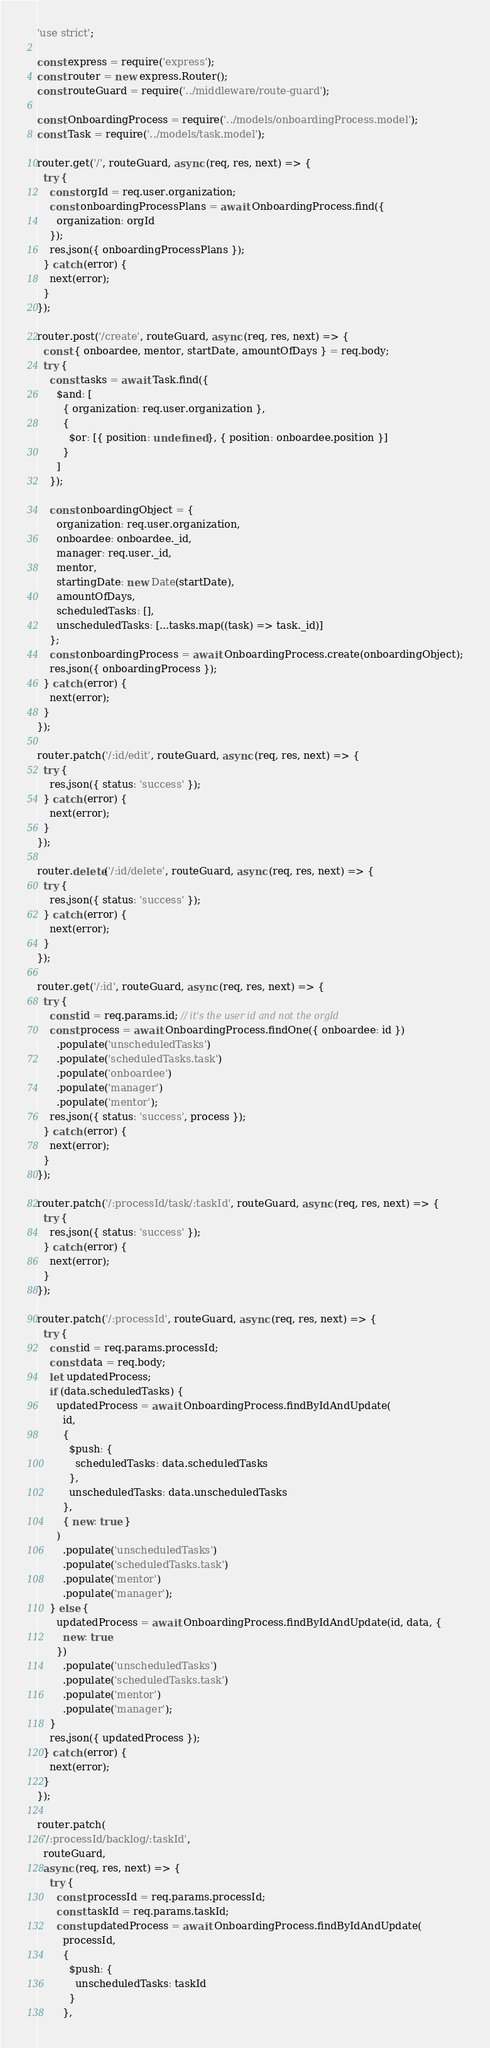<code> <loc_0><loc_0><loc_500><loc_500><_JavaScript_>'use strict';

const express = require('express');
const router = new express.Router();
const routeGuard = require('../middleware/route-guard');

const OnboardingProcess = require('../models/onboardingProcess.model');
const Task = require('../models/task.model');

router.get('/', routeGuard, async (req, res, next) => {
  try {
    const orgId = req.user.organization;
    const onboardingProcessPlans = await OnboardingProcess.find({
      organization: orgId
    });
    res.json({ onboardingProcessPlans });
  } catch (error) {
    next(error);
  }
});

router.post('/create', routeGuard, async (req, res, next) => {
  const { onboardee, mentor, startDate, amountOfDays } = req.body;
  try {
    const tasks = await Task.find({
      $and: [
        { organization: req.user.organization },
        {
          $or: [{ position: undefined }, { position: onboardee.position }]
        }
      ]
    });

    const onboardingObject = {
      organization: req.user.organization,
      onboardee: onboardee._id,
      manager: req.user._id,
      mentor,
      startingDate: new Date(startDate),
      amountOfDays,
      scheduledTasks: [],
      unscheduledTasks: [...tasks.map((task) => task._id)]
    };
    const onboardingProcess = await OnboardingProcess.create(onboardingObject);
    res.json({ onboardingProcess });
  } catch (error) {
    next(error);
  }
});

router.patch('/:id/edit', routeGuard, async (req, res, next) => {
  try {
    res.json({ status: 'success' });
  } catch (error) {
    next(error);
  }
});

router.delete('/:id/delete', routeGuard, async (req, res, next) => {
  try {
    res.json({ status: 'success' });
  } catch (error) {
    next(error);
  }
});

router.get('/:id', routeGuard, async (req, res, next) => {
  try {
    const id = req.params.id; // it's the user id and not the orgId
    const process = await OnboardingProcess.findOne({ onboardee: id })
      .populate('unscheduledTasks')
      .populate('scheduledTasks.task')
      .populate('onboardee')
      .populate('manager')
      .populate('mentor');
    res.json({ status: 'success', process });
  } catch (error) {
    next(error);
  }
});

router.patch('/:processId/task/:taskId', routeGuard, async (req, res, next) => {
  try {
    res.json({ status: 'success' });
  } catch (error) {
    next(error);
  }
});

router.patch('/:processId', routeGuard, async (req, res, next) => {
  try {
    const id = req.params.processId;
    const data = req.body;
    let updatedProcess;
    if (data.scheduledTasks) {
      updatedProcess = await OnboardingProcess.findByIdAndUpdate(
        id,
        {
          $push: {
            scheduledTasks: data.scheduledTasks
          },
          unscheduledTasks: data.unscheduledTasks
        },
        { new: true }
      )
        .populate('unscheduledTasks')
        .populate('scheduledTasks.task')
        .populate('mentor')
        .populate('manager');
    } else {
      updatedProcess = await OnboardingProcess.findByIdAndUpdate(id, data, {
        new: true
      })
        .populate('unscheduledTasks')
        .populate('scheduledTasks.task')
        .populate('mentor')
        .populate('manager');
    }
    res.json({ updatedProcess });
  } catch (error) {
    next(error);
  }
});

router.patch(
  '/:processId/backlog/:taskId',
  routeGuard,
  async (req, res, next) => {
    try {
      const processId = req.params.processId;
      const taskId = req.params.taskId;
      const updatedProcess = await OnboardingProcess.findByIdAndUpdate(
        processId,
        {
          $push: {
            unscheduledTasks: taskId
          }
        },</code> 